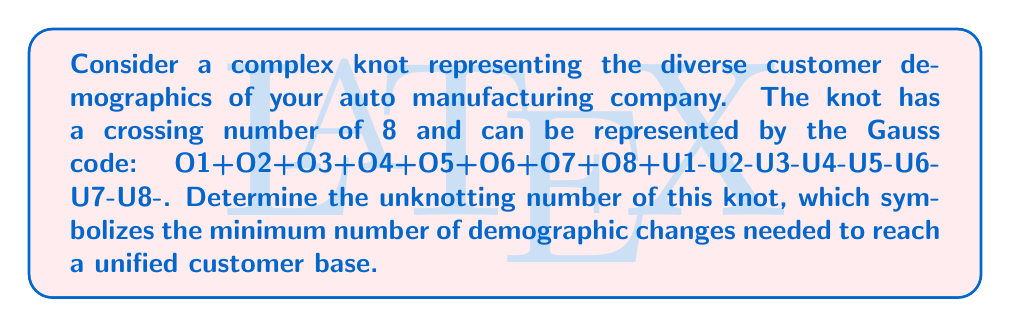Could you help me with this problem? To determine the unknotting number of this complex knot, we'll follow these steps:

1. Analyze the Gauss code:
   The Gauss code O1+O2+O3+O4+O5+O6+O7+O8+U1-U2-U3-U4-U5-U6-U7-U8- represents a knot with 8 crossings.

2. Identify the knot type:
   This Gauss code corresponds to the 8₁₉ knot in the Rolfsen table.

3. Use known properties of the 8₁₉ knot:
   The 8₁₉ knot is known to have an unknotting number of 3.

4. Interpret the result:
   The unknotting number of 3 means that a minimum of 3 crossing changes are required to transform this knot into the unknot (trivial knot).

5. In the context of customer demographics:
   Each crossing change represents a demographic shift or integration effort needed to unify the customer base.

The unknotting number provides a measure of the complexity in unifying diverse customer groups, with each change symbolizing a strategic marketing initiative to bridge demographic differences.
Answer: 3 